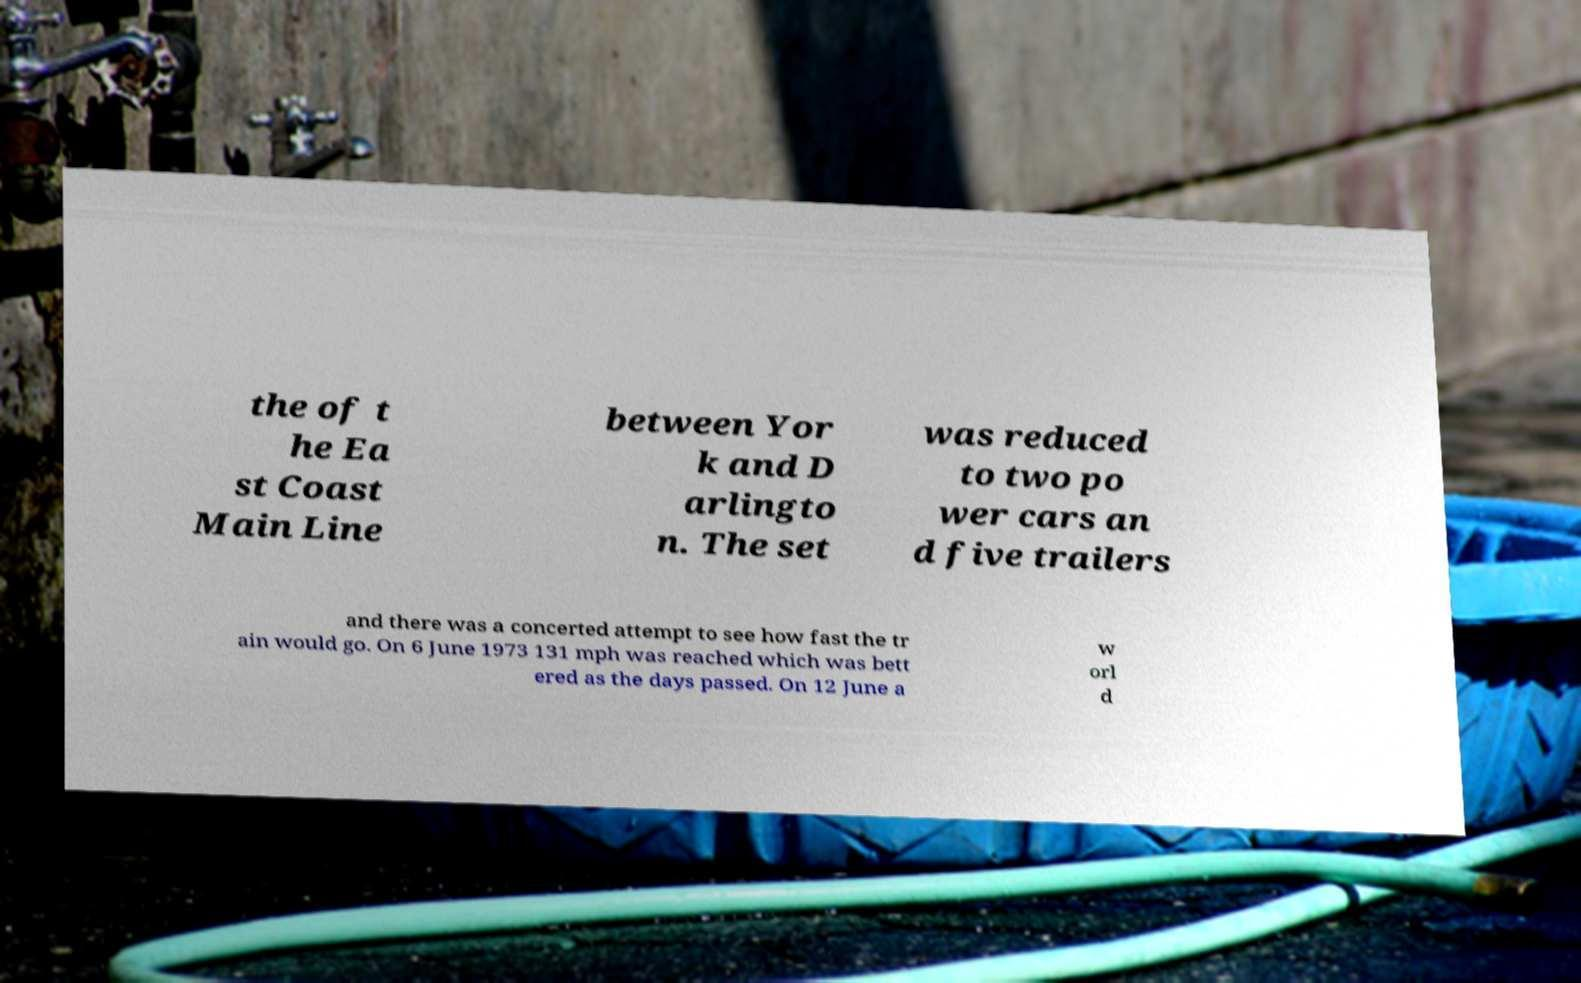Can you accurately transcribe the text from the provided image for me? the of t he Ea st Coast Main Line between Yor k and D arlingto n. The set was reduced to two po wer cars an d five trailers and there was a concerted attempt to see how fast the tr ain would go. On 6 June 1973 131 mph was reached which was bett ered as the days passed. On 12 June a w orl d 